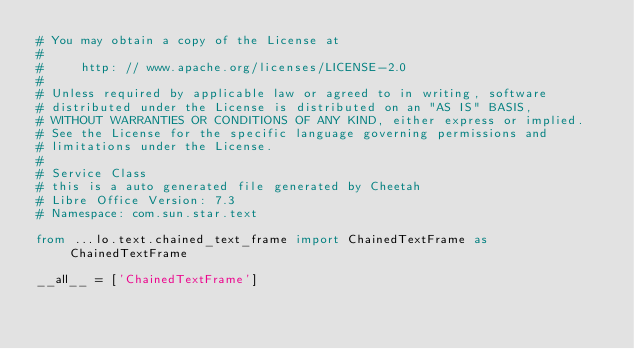Convert code to text. <code><loc_0><loc_0><loc_500><loc_500><_Python_># You may obtain a copy of the License at
#
#     http: // www.apache.org/licenses/LICENSE-2.0
#
# Unless required by applicable law or agreed to in writing, software
# distributed under the License is distributed on an "AS IS" BASIS,
# WITHOUT WARRANTIES OR CONDITIONS OF ANY KIND, either express or implied.
# See the License for the specific language governing permissions and
# limitations under the License.
#
# Service Class
# this is a auto generated file generated by Cheetah
# Libre Office Version: 7.3
# Namespace: com.sun.star.text

from ...lo.text.chained_text_frame import ChainedTextFrame as ChainedTextFrame

__all__ = ['ChainedTextFrame']

</code> 